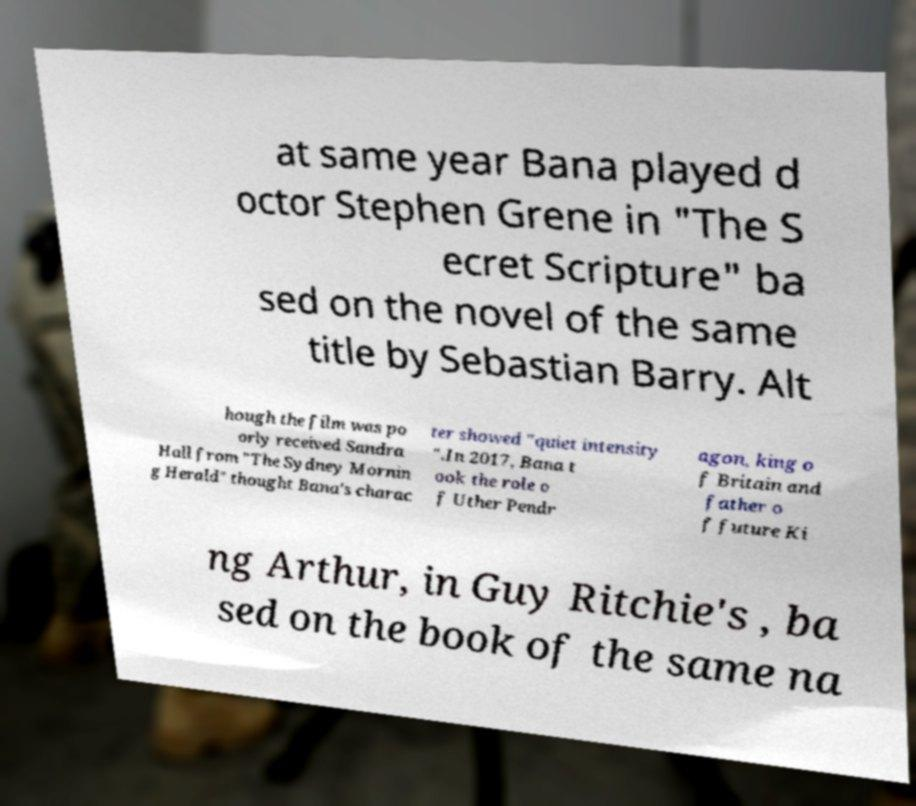I need the written content from this picture converted into text. Can you do that? at same year Bana played d octor Stephen Grene in "The S ecret Scripture" ba sed on the novel of the same title by Sebastian Barry. Alt hough the film was po orly received Sandra Hall from "The Sydney Mornin g Herald" thought Bana's charac ter showed "quiet intensity ".In 2017, Bana t ook the role o f Uther Pendr agon, king o f Britain and father o f future Ki ng Arthur, in Guy Ritchie's , ba sed on the book of the same na 